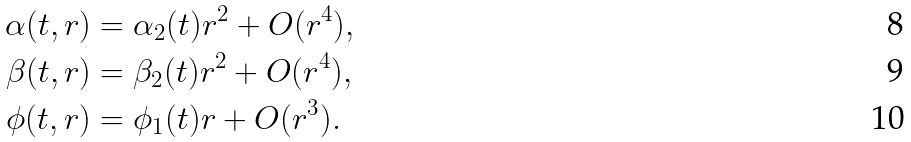Convert formula to latex. <formula><loc_0><loc_0><loc_500><loc_500>\alpha ( t , r ) & = \alpha _ { 2 } ( t ) r ^ { 2 } + O ( r ^ { 4 } ) , \\ \beta ( t , r ) & = \beta _ { 2 } ( t ) r ^ { 2 } + O ( r ^ { 4 } ) , \\ \phi ( t , r ) & = \phi _ { 1 } ( t ) r + O ( r ^ { 3 } ) .</formula> 